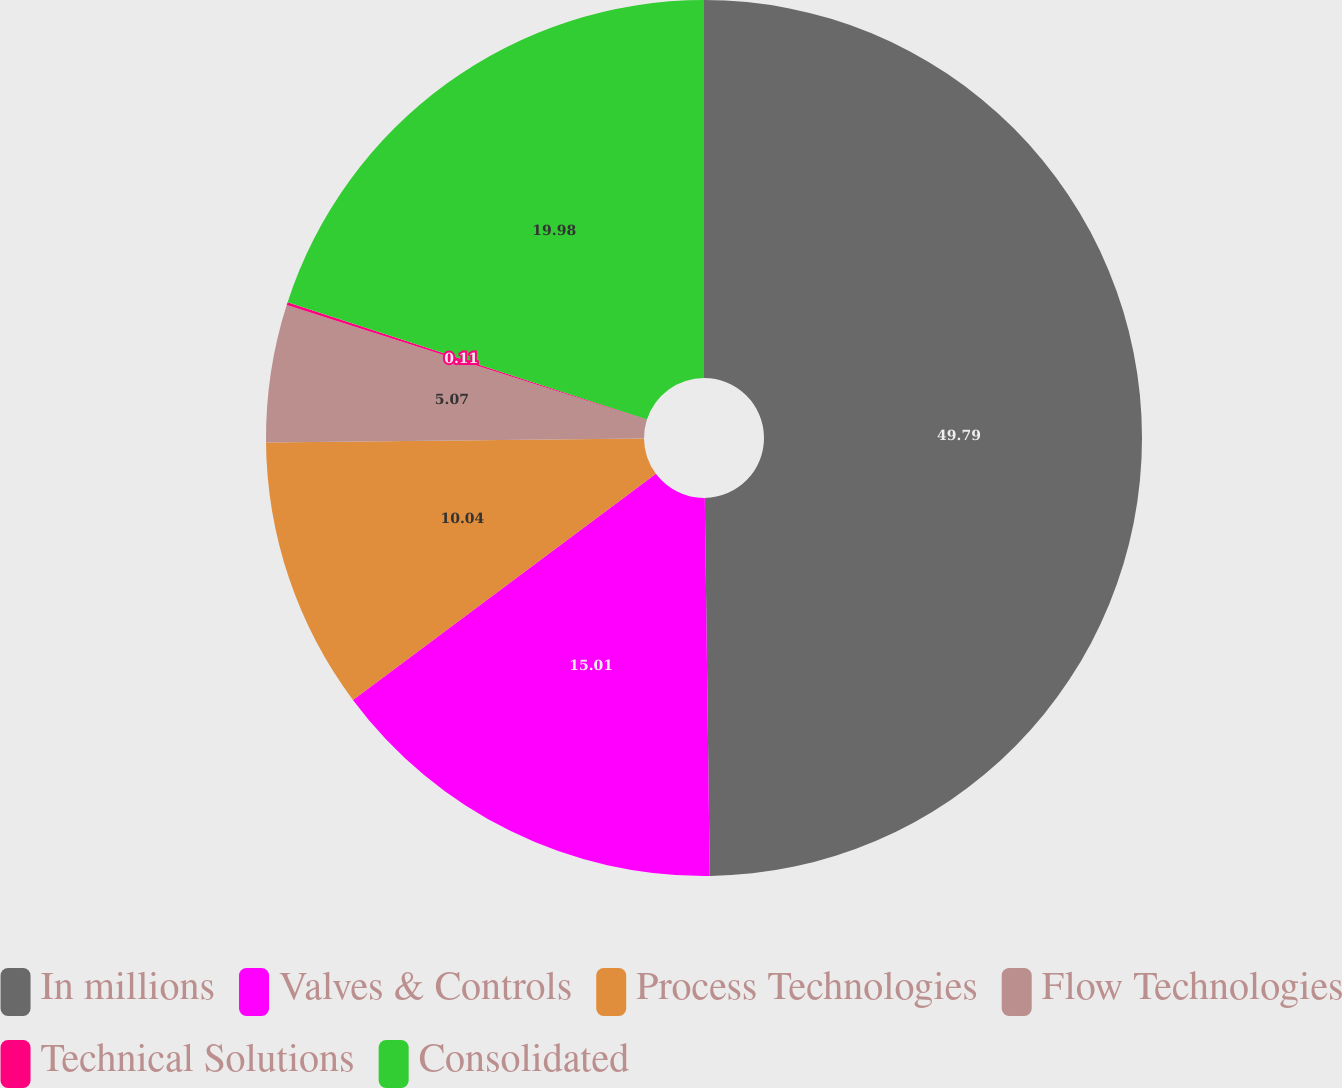<chart> <loc_0><loc_0><loc_500><loc_500><pie_chart><fcel>In millions<fcel>Valves & Controls<fcel>Process Technologies<fcel>Flow Technologies<fcel>Technical Solutions<fcel>Consolidated<nl><fcel>49.79%<fcel>15.01%<fcel>10.04%<fcel>5.07%<fcel>0.11%<fcel>19.98%<nl></chart> 